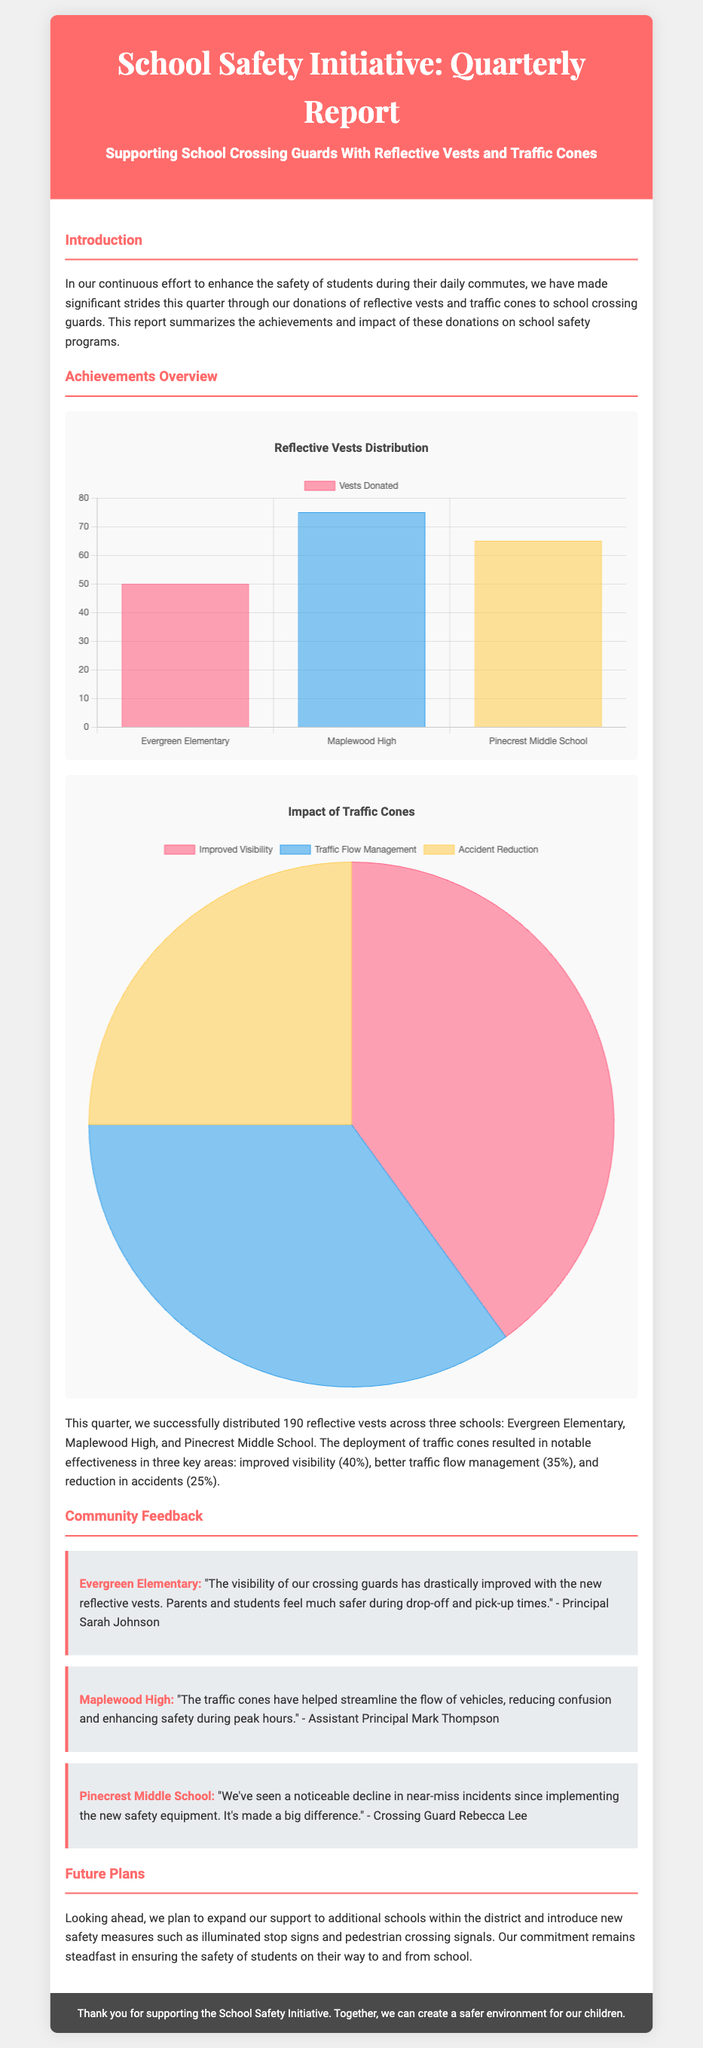What is the title of the report? The title of the report is provided in the header section, summarizing the main focus of the document.
Answer: School Safety Initiative: Quarterly Report How many reflective vests were distributed? The document specifies the total number of reflective vests donated across three schools in the Achievements Overview section.
Answer: 190 Which school received the most vests? The specific number of vests distributed to each school is mentioned in the Achievements Overview.
Answer: Maplewood High What percentage of improvement was noted in visibility? The document outlines the effectiveness of traffic cones, including statistics for visibility improvement.
Answer: 40% Who is the principal of Evergreen Elementary? The feedback section attributes the quoted statement to a specific individual associated with Evergreen Elementary.
Answer: Sarah Johnson What future safety measure is mentioned for implementation? The Future Plans section discusses new safety measures to be introduced, indicating the direction of future initiatives.
Answer: Illuminated stop signs What is the color theme of the report? The dominant colors used in the report's design can be inferred from the header and various sections.
Answer: Red and gray What type of chart displays the reflective vest distribution? The chart type used for showcasing the distribution of reflective vests can be identified in the document.
Answer: Bar What is the main goal of the School Safety Initiative? The introduction section provides a brief overview of the initiative's objectives regarding student safety.
Answer: Enhance the safety of students 